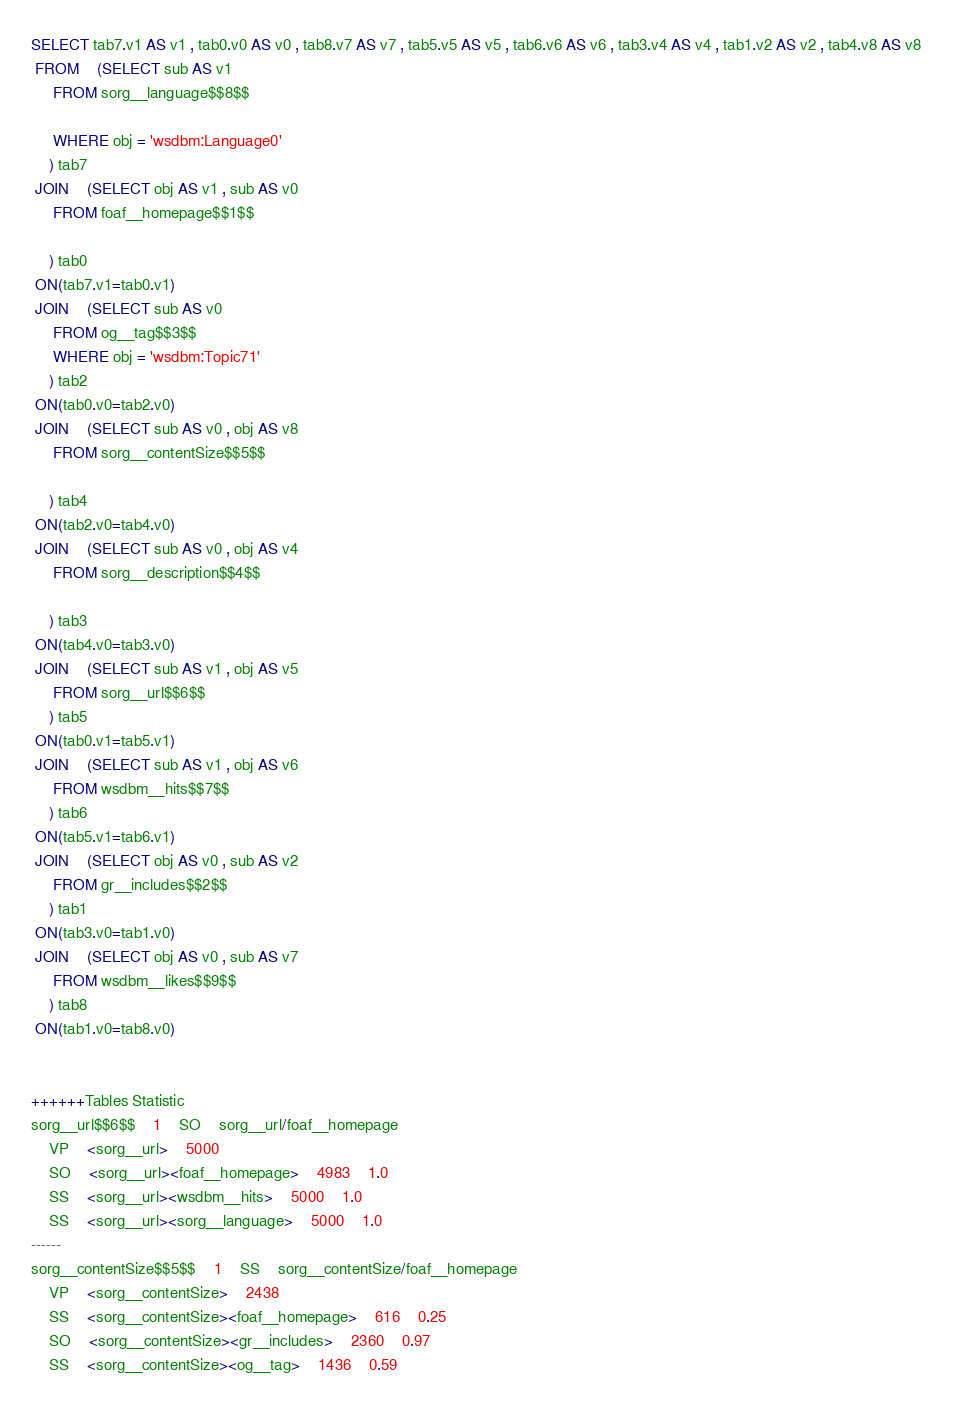Convert code to text. <code><loc_0><loc_0><loc_500><loc_500><_SQL_>SELECT tab7.v1 AS v1 , tab0.v0 AS v0 , tab8.v7 AS v7 , tab5.v5 AS v5 , tab6.v6 AS v6 , tab3.v4 AS v4 , tab1.v2 AS v2 , tab4.v8 AS v8 
 FROM    (SELECT sub AS v1 
	 FROM sorg__language$$8$$
	 
	 WHERE obj = 'wsdbm:Language0'
	) tab7
 JOIN    (SELECT obj AS v1 , sub AS v0 
	 FROM foaf__homepage$$1$$
	
	) tab0
 ON(tab7.v1=tab0.v1)
 JOIN    (SELECT sub AS v0 
	 FROM og__tag$$3$$ 
	 WHERE obj = 'wsdbm:Topic71'
	) tab2
 ON(tab0.v0=tab2.v0)
 JOIN    (SELECT sub AS v0 , obj AS v8 
	 FROM sorg__contentSize$$5$$
	
	) tab4
 ON(tab2.v0=tab4.v0)
 JOIN    (SELECT sub AS v0 , obj AS v4 
	 FROM sorg__description$$4$$
	
	) tab3
 ON(tab4.v0=tab3.v0)
 JOIN    (SELECT sub AS v1 , obj AS v5 
	 FROM sorg__url$$6$$
	) tab5
 ON(tab0.v1=tab5.v1)
 JOIN    (SELECT sub AS v1 , obj AS v6 
	 FROM wsdbm__hits$$7$$
	) tab6
 ON(tab5.v1=tab6.v1)
 JOIN    (SELECT obj AS v0 , sub AS v2 
	 FROM gr__includes$$2$$
	) tab1
 ON(tab3.v0=tab1.v0)
 JOIN    (SELECT obj AS v0 , sub AS v7 
	 FROM wsdbm__likes$$9$$
	) tab8
 ON(tab1.v0=tab8.v0)


++++++Tables Statistic
sorg__url$$6$$	1	SO	sorg__url/foaf__homepage
	VP	<sorg__url>	5000
	SO	<sorg__url><foaf__homepage>	4983	1.0
	SS	<sorg__url><wsdbm__hits>	5000	1.0
	SS	<sorg__url><sorg__language>	5000	1.0
------
sorg__contentSize$$5$$	1	SS	sorg__contentSize/foaf__homepage
	VP	<sorg__contentSize>	2438
	SS	<sorg__contentSize><foaf__homepage>	616	0.25
	SO	<sorg__contentSize><gr__includes>	2360	0.97
	SS	<sorg__contentSize><og__tag>	1436	0.59</code> 